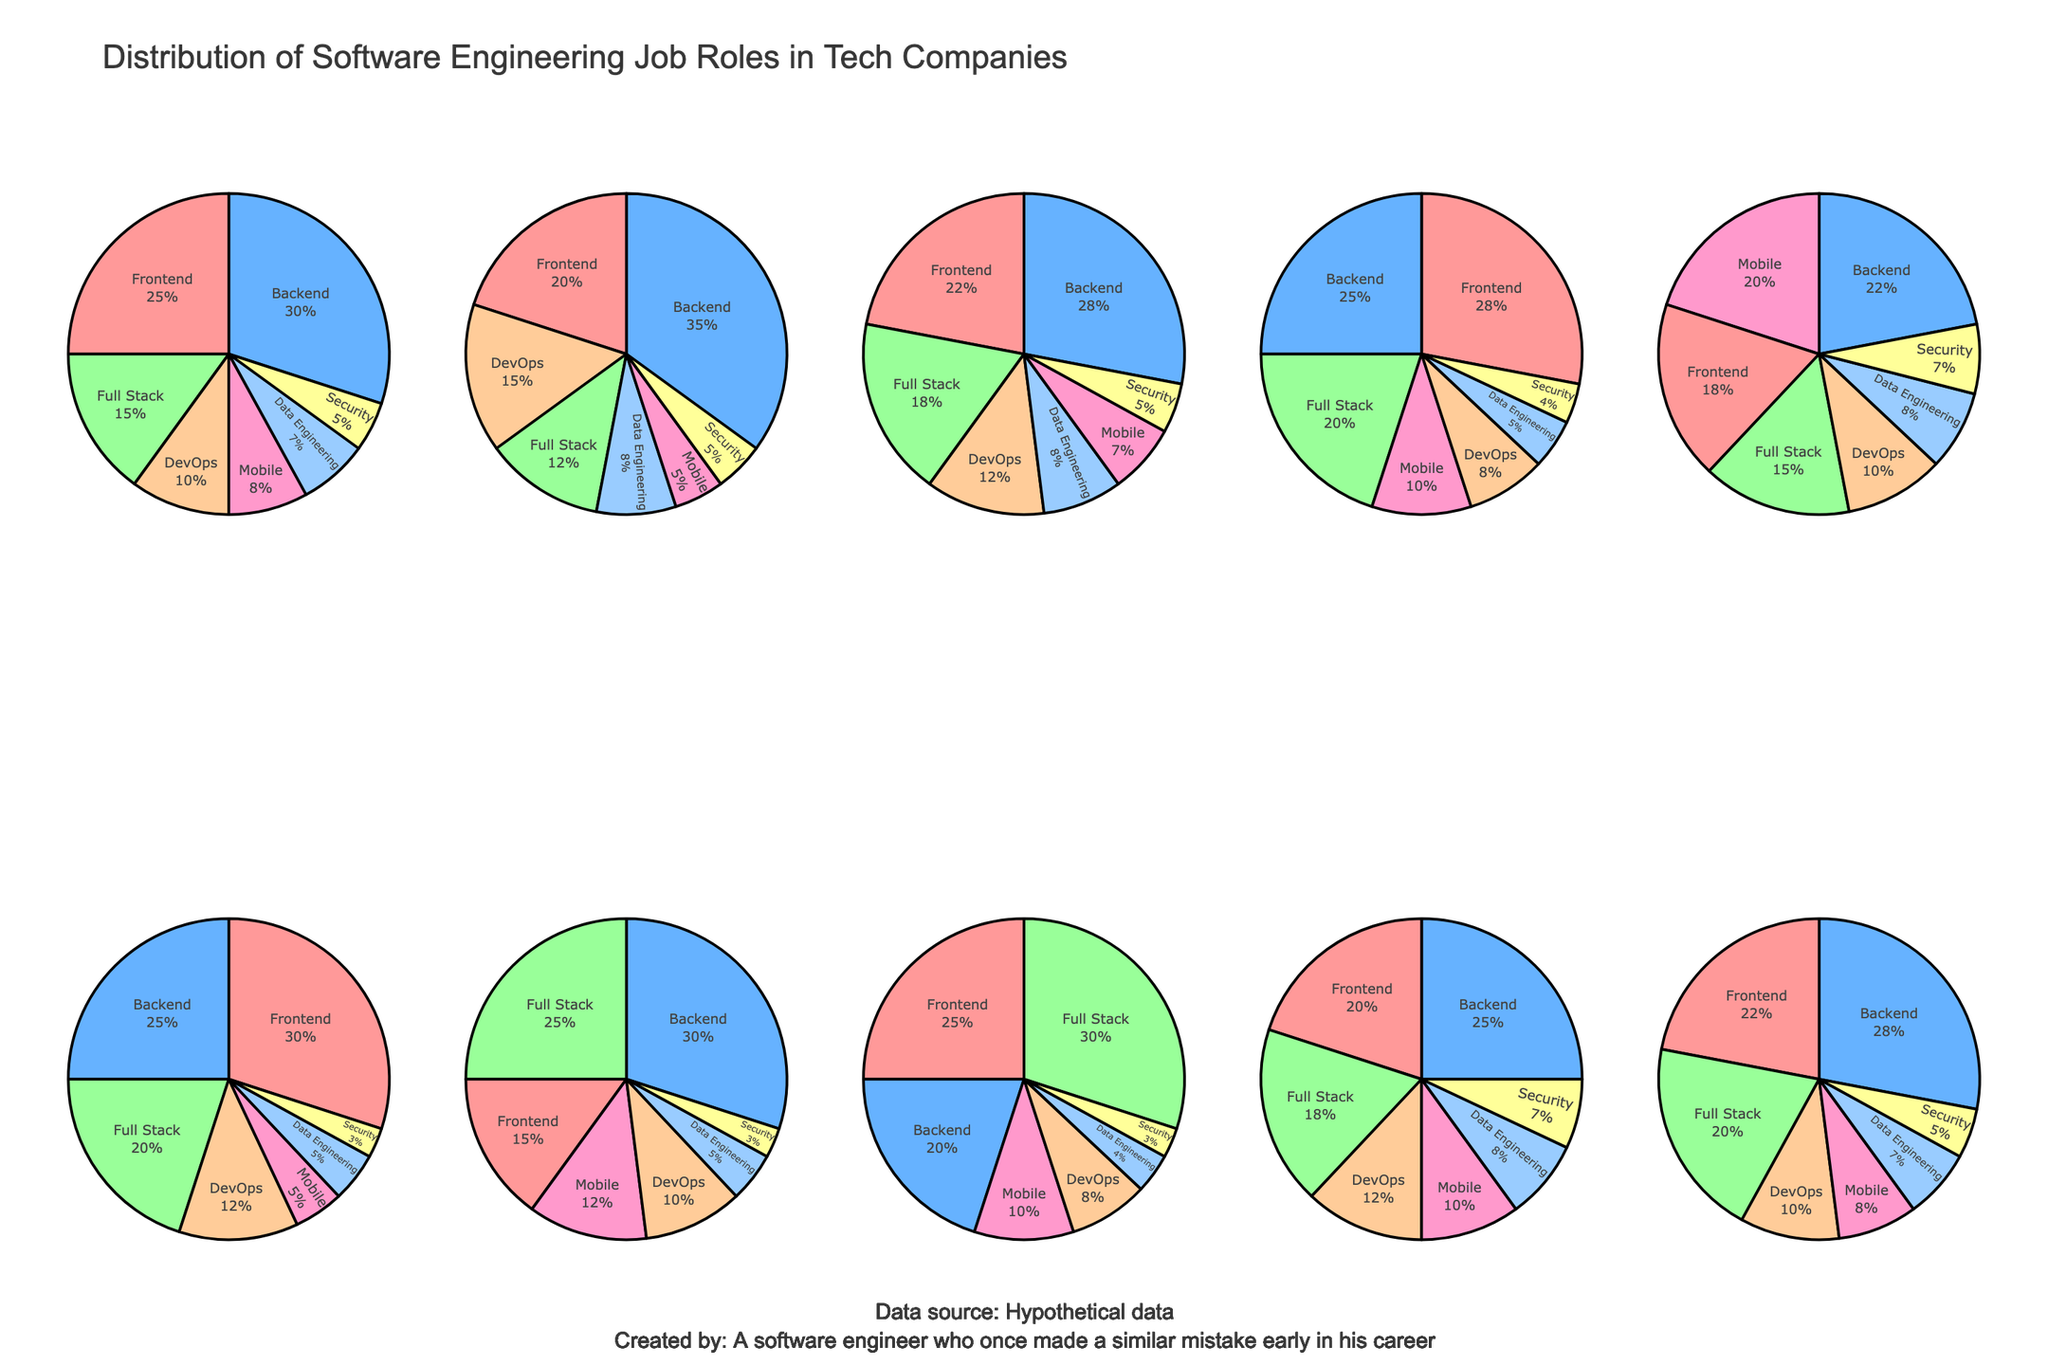Which company has the highest percentage of Full Stack roles? By looking at the pie charts, identify the company with the largest slice corresponding to Full Stack roles. Airbnb has the largest Full Stack slice at 30%.
Answer: Airbnb Which company has the smallest percentage of Data Engineering roles? By observing the pie charts, note the smallest slice for Data Engineering roles. Netflix, with a slice of 5%, has the smallest percentage for Data Engineering roles.
Answer: Netflix What is the title of the figure? The title is prominently displayed at the top of the chart. It reads "Distribution of Software Engineering Job Roles in Tech Companies".
Answer: Distribution of Software Engineering Job Roles in Tech Companies What are the categories of job roles represented in the pie charts? The pie chart labels list the different job roles. They include Frontend, Backend, Full Stack, DevOps, Mobile, Data Engineering, and Security.
Answer: Frontend, Backend, Full Stack, DevOps, Mobile, Data Engineering, Security Which company has the most balanced distribution among all categories? By comparing the sizes of the slices, look for the chart where slices are nearly equal. Microsoft appears the most balanced with no category overwhelmingly larger than the others.
Answer: Microsoft Which job role is the most common at Apple? By examining Apple's pie chart, identify the largest slice, which represents the most common job role. Mobile has the largest slice at 20%.
Answer: Mobile Among Google, Facebook, and Twitter, which company has the largest percentage of DevOps roles? Compare the slices for DevOps roles in Google, Facebook, and Twitter. Amazon has the highest percentage for DevOps at 15%.
Answer: Amazon What company has the lowest percentage of Security roles? Observing each company’s pie chart, identify the smallest Security slice. Netflix and Uber both have the smallest Security slice at 3%.
Answer: Netflix and Uber What is the sum of Backend role percentages for Amazon and Uber? Find the Backend slices for Amazon and Uber, sum up the percentages: 35% (Amazon) + 30% (Uber) = 65%.
Answer: 65% What company has the highest percentage dedicated to Frontend roles? Look for the largest Frontend slice across all pie charts. Netflix has the highest at 30%.
Answer: Netflix 